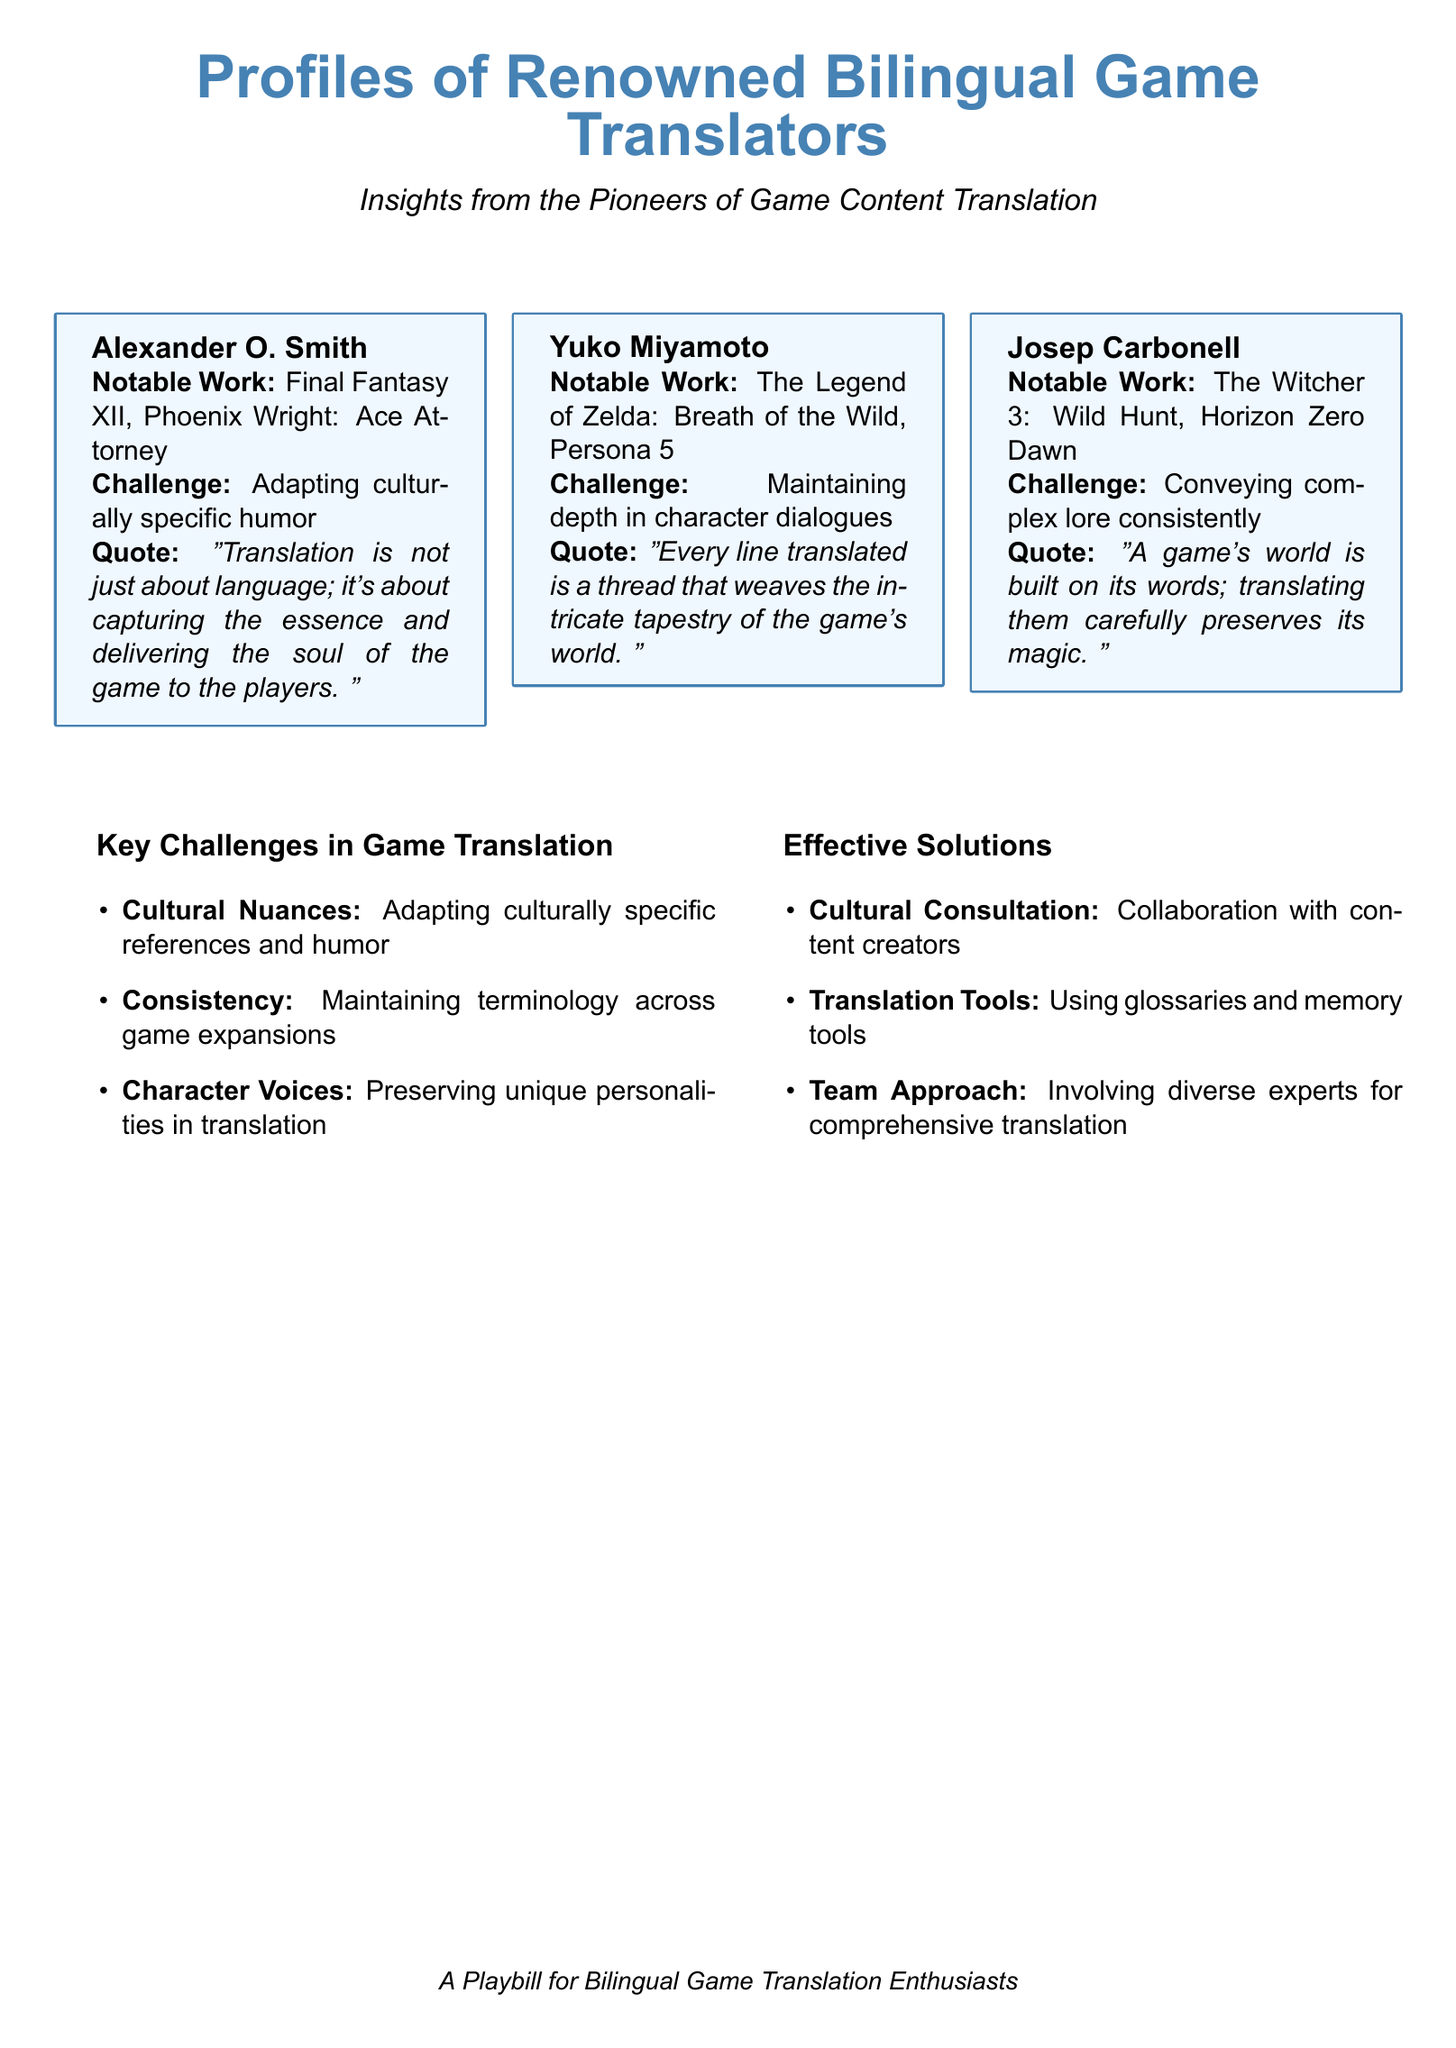What is the name of the first translator listed? The first translator mentioned in the document is listed as Alexander O. Smith.
Answer: Alexander O. Smith Which game did Yuko Miyamoto translate? The document lists notable work by Yuko Miyamoto, including The Legend of Zelda: Breath of the Wild.
Answer: The Legend of Zelda: Breath of the Wild What challenge is associated with Josep Carbonell? The document states that Josep Carbonell's challenge is conveying complex lore consistently.
Answer: Conveying complex lore consistently What is the notable work of Alexander O. Smith? Notable works associated with Alexander O. Smith include Final Fantasy XII and Phoenix Wright: Ace Attorney.
Answer: Final Fantasy XII, Phoenix Wright: Ace Attorney Which solution involves collaboration with content creators? The solution that involves collaboration with content creators is labeled as Cultural Consultation in the document.
Answer: Cultural Consultation What type of document is this? The document is described as a Playbill, specifically for bilingual game translation enthusiasts.
Answer: Playbill What does the quote from Yuko Miyamoto emphasize? Yuko Miyamoto's quote emphasizes the importance of every line translated in weaving the tapestry of the game's world.
Answer: Weaving the intricate tapestry of the game's world How many key challenges are listed in the document? The document lists three key challenges in game translation.
Answer: Three What is a key solution related to terminology? The key solution related to terminology involves using glossaries and memory tools.
Answer: Using glossaries and memory tools 